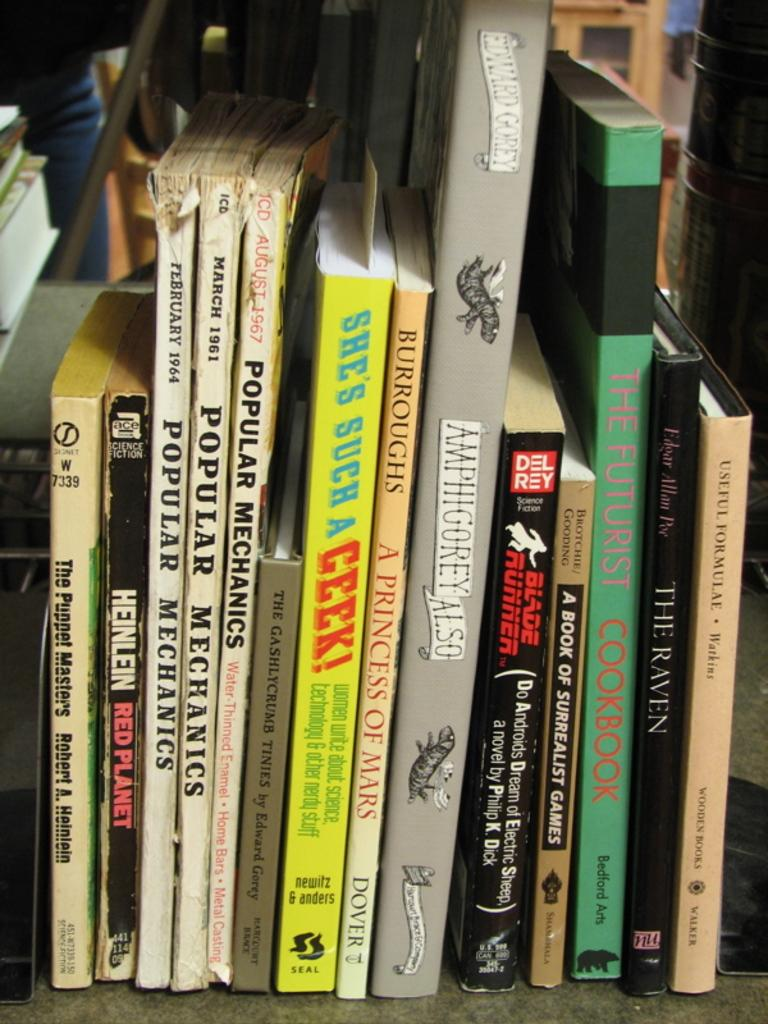Provide a one-sentence caption for the provided image. Several books sit on a shelf, in particular there are 3 Popular mechanics books. 